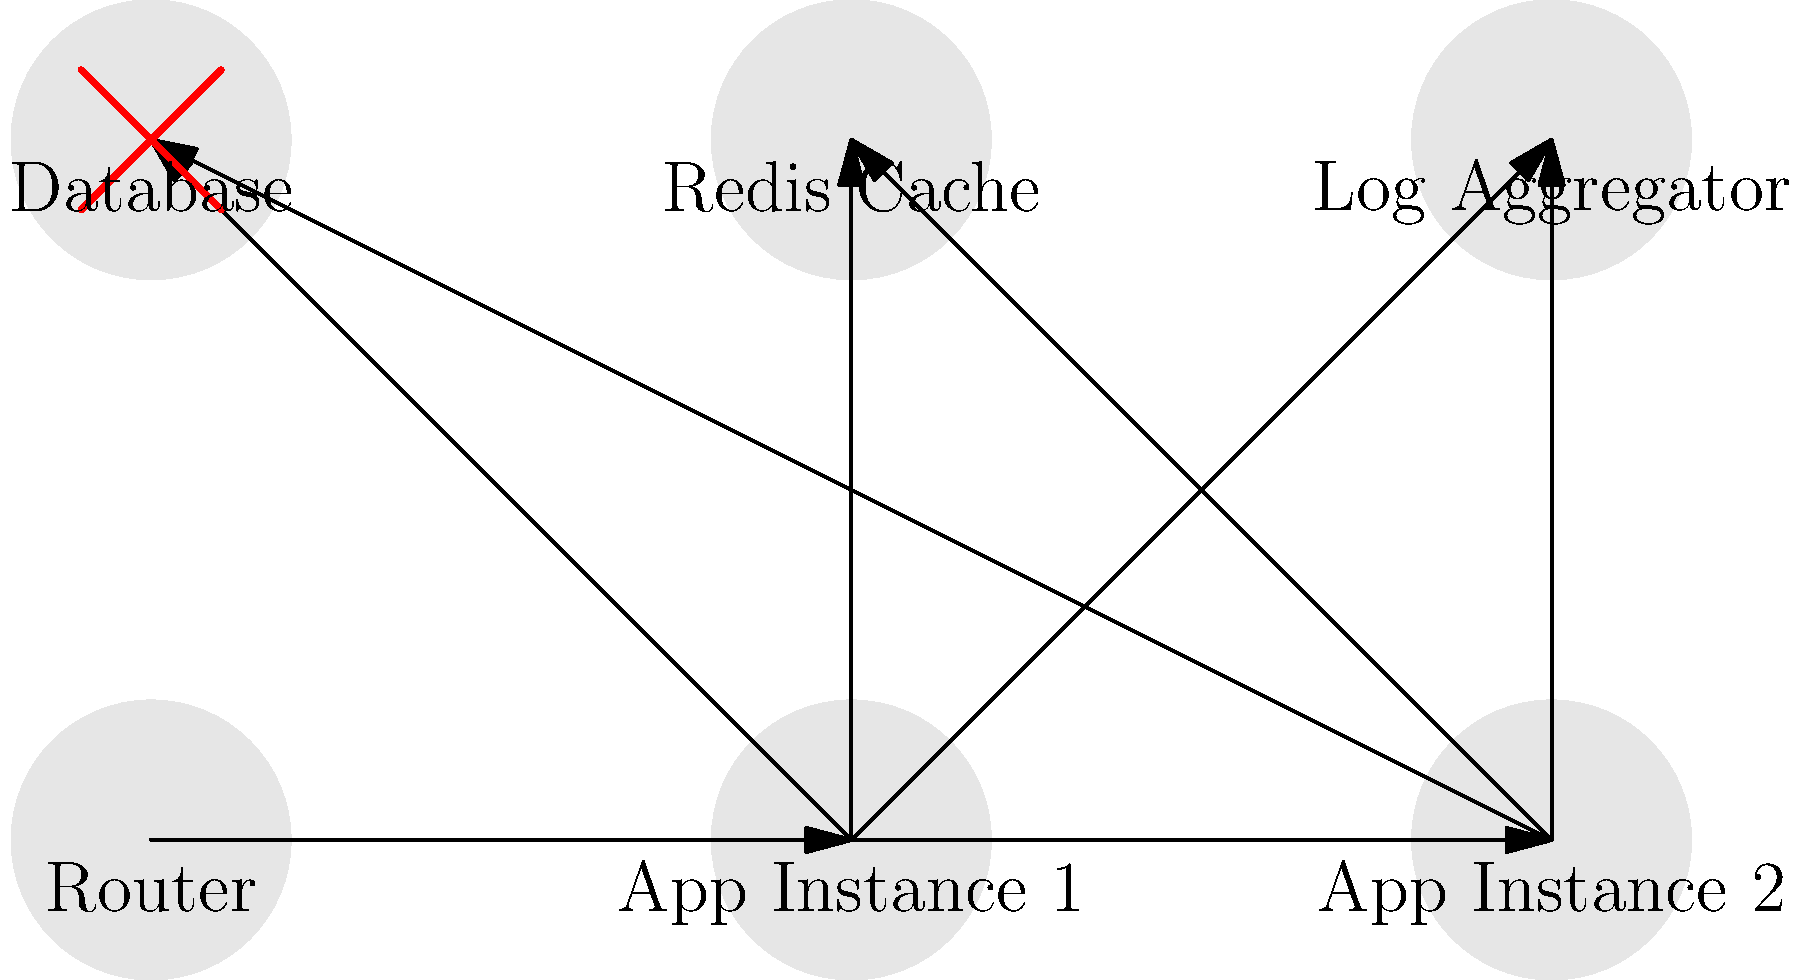In the CloudFoundry application deployment diagram above, which component is likely causing a bottleneck in the system, and what could be a potential solution to improve performance? To identify the bottleneck and propose a solution, let's analyze the diagram step-by-step:

1. The diagram shows a typical CloudFoundry deployment with a Router, two App Instances, a Database, a Redis Cache, and a Log Aggregator.

2. All connections seem to flow smoothly, except for the Database component, which has a red "X" symbol overlaid on it.

3. Both App Instances are connected to the Database, indicating that it's a shared resource.

4. The red "X" on the Database suggests that it's experiencing high load or performance issues.

5. Given that the Database is a shared resource and is marked as problematic, it's likely the bottleneck in this system.

6. To improve performance, we can consider the following solutions:
   a. Scale the Database horizontally by adding more instances and implementing a database cluster.
   b. Optimize database queries and indexes to improve response times.
   c. Implement more aggressive caching strategies using the Redis Cache to reduce database load.
   d. Consider using a database proxy like PgBouncer for PostgreSQL to manage database connections more efficiently.

7. Among these options, implementing more aggressive caching with Redis is likely the quickest and most effective solution, as it's already part of the architecture.

Therefore, the bottleneck is the Database, and a potential solution is to implement more aggressive caching strategies using the existing Redis Cache.
Answer: Database; Implement more aggressive Redis caching 